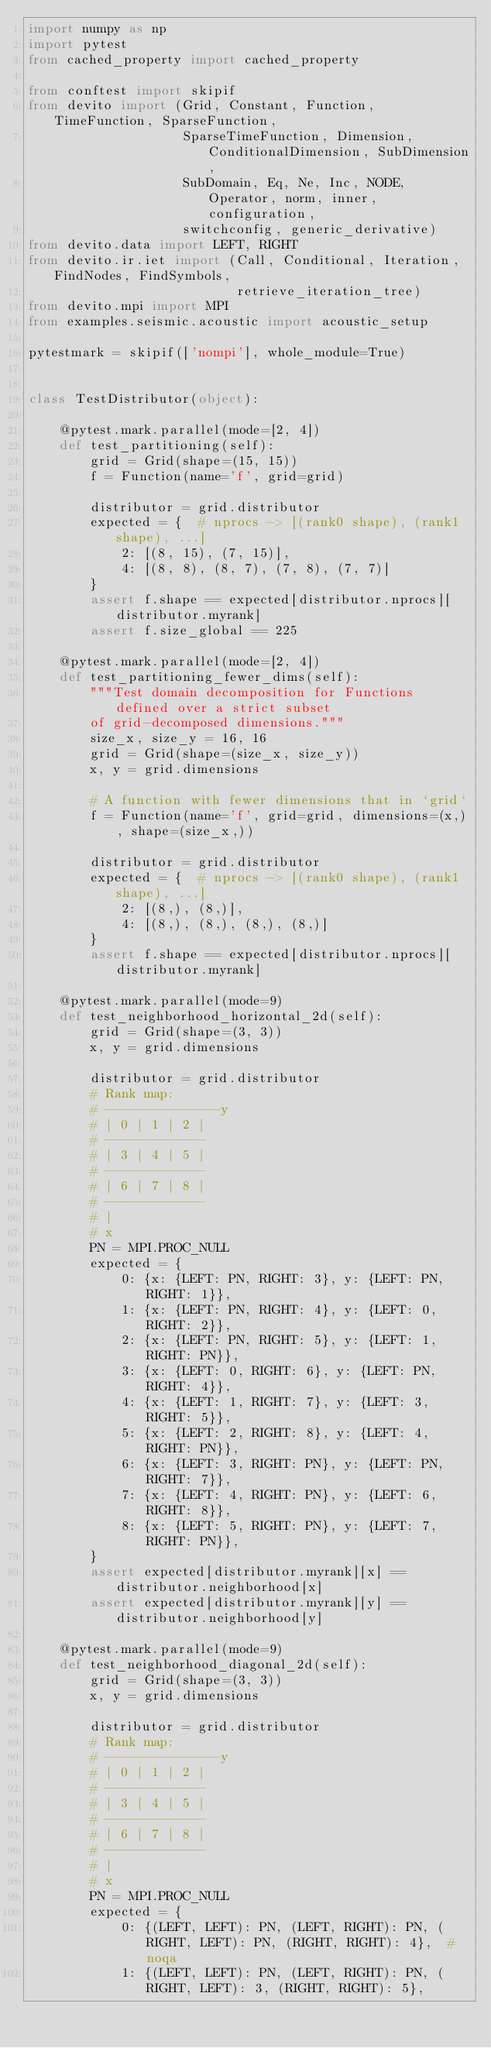Convert code to text. <code><loc_0><loc_0><loc_500><loc_500><_Python_>import numpy as np
import pytest
from cached_property import cached_property

from conftest import skipif
from devito import (Grid, Constant, Function, TimeFunction, SparseFunction,
                    SparseTimeFunction, Dimension, ConditionalDimension, SubDimension,
                    SubDomain, Eq, Ne, Inc, NODE, Operator, norm, inner, configuration,
                    switchconfig, generic_derivative)
from devito.data import LEFT, RIGHT
from devito.ir.iet import (Call, Conditional, Iteration, FindNodes, FindSymbols,
                           retrieve_iteration_tree)
from devito.mpi import MPI
from examples.seismic.acoustic import acoustic_setup

pytestmark = skipif(['nompi'], whole_module=True)


class TestDistributor(object):

    @pytest.mark.parallel(mode=[2, 4])
    def test_partitioning(self):
        grid = Grid(shape=(15, 15))
        f = Function(name='f', grid=grid)

        distributor = grid.distributor
        expected = {  # nprocs -> [(rank0 shape), (rank1 shape), ...]
            2: [(8, 15), (7, 15)],
            4: [(8, 8), (8, 7), (7, 8), (7, 7)]
        }
        assert f.shape == expected[distributor.nprocs][distributor.myrank]
        assert f.size_global == 225

    @pytest.mark.parallel(mode=[2, 4])
    def test_partitioning_fewer_dims(self):
        """Test domain decomposition for Functions defined over a strict subset
        of grid-decomposed dimensions."""
        size_x, size_y = 16, 16
        grid = Grid(shape=(size_x, size_y))
        x, y = grid.dimensions

        # A function with fewer dimensions that in `grid`
        f = Function(name='f', grid=grid, dimensions=(x,), shape=(size_x,))

        distributor = grid.distributor
        expected = {  # nprocs -> [(rank0 shape), (rank1 shape), ...]
            2: [(8,), (8,)],
            4: [(8,), (8,), (8,), (8,)]
        }
        assert f.shape == expected[distributor.nprocs][distributor.myrank]

    @pytest.mark.parallel(mode=9)
    def test_neighborhood_horizontal_2d(self):
        grid = Grid(shape=(3, 3))
        x, y = grid.dimensions

        distributor = grid.distributor
        # Rank map:
        # ---------------y
        # | 0 | 1 | 2 |
        # -------------
        # | 3 | 4 | 5 |
        # -------------
        # | 6 | 7 | 8 |
        # -------------
        # |
        # x
        PN = MPI.PROC_NULL
        expected = {
            0: {x: {LEFT: PN, RIGHT: 3}, y: {LEFT: PN, RIGHT: 1}},
            1: {x: {LEFT: PN, RIGHT: 4}, y: {LEFT: 0, RIGHT: 2}},
            2: {x: {LEFT: PN, RIGHT: 5}, y: {LEFT: 1, RIGHT: PN}},
            3: {x: {LEFT: 0, RIGHT: 6}, y: {LEFT: PN, RIGHT: 4}},
            4: {x: {LEFT: 1, RIGHT: 7}, y: {LEFT: 3, RIGHT: 5}},
            5: {x: {LEFT: 2, RIGHT: 8}, y: {LEFT: 4, RIGHT: PN}},
            6: {x: {LEFT: 3, RIGHT: PN}, y: {LEFT: PN, RIGHT: 7}},
            7: {x: {LEFT: 4, RIGHT: PN}, y: {LEFT: 6, RIGHT: 8}},
            8: {x: {LEFT: 5, RIGHT: PN}, y: {LEFT: 7, RIGHT: PN}},
        }
        assert expected[distributor.myrank][x] == distributor.neighborhood[x]
        assert expected[distributor.myrank][y] == distributor.neighborhood[y]

    @pytest.mark.parallel(mode=9)
    def test_neighborhood_diagonal_2d(self):
        grid = Grid(shape=(3, 3))
        x, y = grid.dimensions

        distributor = grid.distributor
        # Rank map:
        # ---------------y
        # | 0 | 1 | 2 |
        # -------------
        # | 3 | 4 | 5 |
        # -------------
        # | 6 | 7 | 8 |
        # -------------
        # |
        # x
        PN = MPI.PROC_NULL
        expected = {
            0: {(LEFT, LEFT): PN, (LEFT, RIGHT): PN, (RIGHT, LEFT): PN, (RIGHT, RIGHT): 4},  # noqa
            1: {(LEFT, LEFT): PN, (LEFT, RIGHT): PN, (RIGHT, LEFT): 3, (RIGHT, RIGHT): 5},</code> 